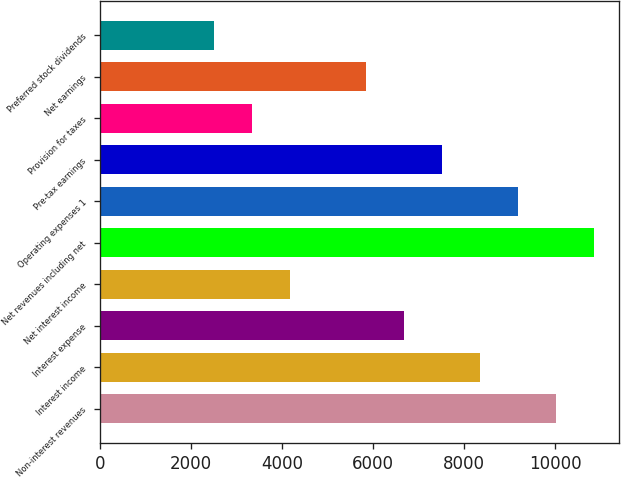Convert chart to OTSL. <chart><loc_0><loc_0><loc_500><loc_500><bar_chart><fcel>Non-interest revenues<fcel>Interest income<fcel>Interest expense<fcel>Net interest income<fcel>Net revenues including net<fcel>Operating expenses 1<fcel>Pre-tax earnings<fcel>Provision for taxes<fcel>Net earnings<fcel>Preferred stock dividends<nl><fcel>10021.1<fcel>8350.96<fcel>6680.86<fcel>4175.71<fcel>10856.1<fcel>9186.01<fcel>7515.91<fcel>3340.66<fcel>5845.81<fcel>2505.61<nl></chart> 